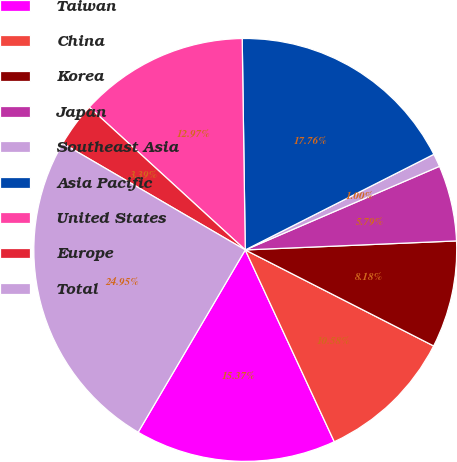<chart> <loc_0><loc_0><loc_500><loc_500><pie_chart><fcel>Taiwan<fcel>China<fcel>Korea<fcel>Japan<fcel>Southeast Asia<fcel>Asia Pacific<fcel>United States<fcel>Europe<fcel>Total<nl><fcel>15.37%<fcel>10.58%<fcel>8.18%<fcel>5.79%<fcel>1.0%<fcel>17.76%<fcel>12.97%<fcel>3.39%<fcel>24.95%<nl></chart> 